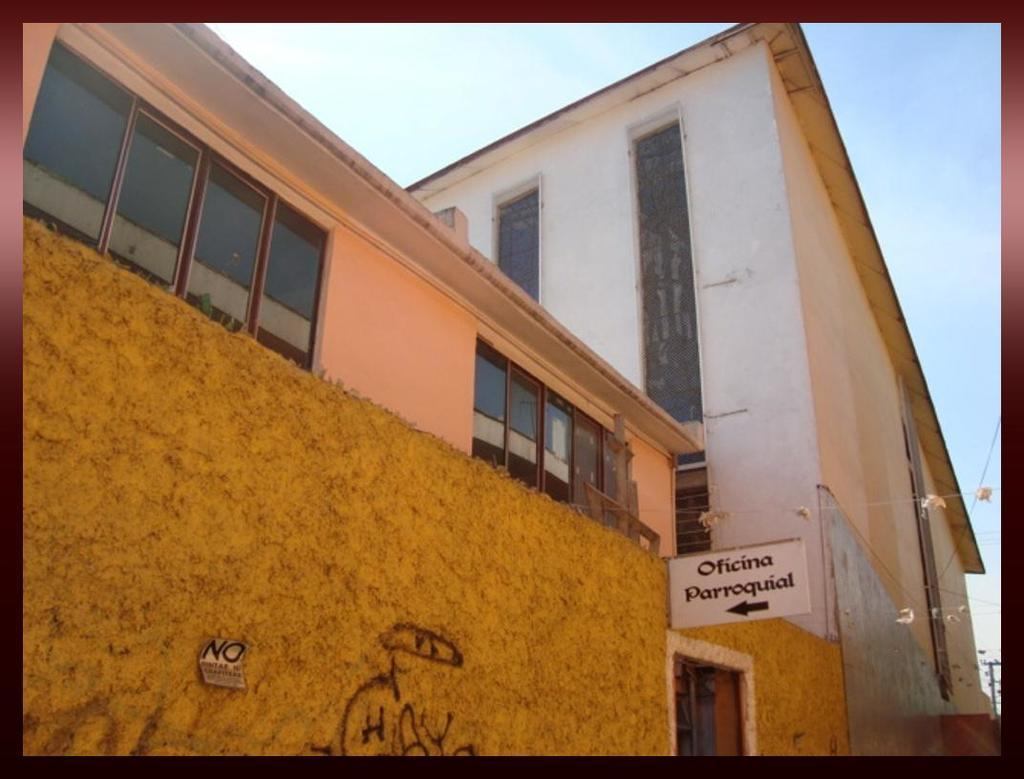What type of structures can be seen in the image? There are buildings in the image. Is there any textual information present in the image? Yes, there is a sign board with text in the image. What type of reward is being given to the person in the image? There is no person present in the image, and therefore no reward can be observed. What adjustments are being made to the buildings in the image? There is no indication of any adjustments being made to the buildings in the image. 